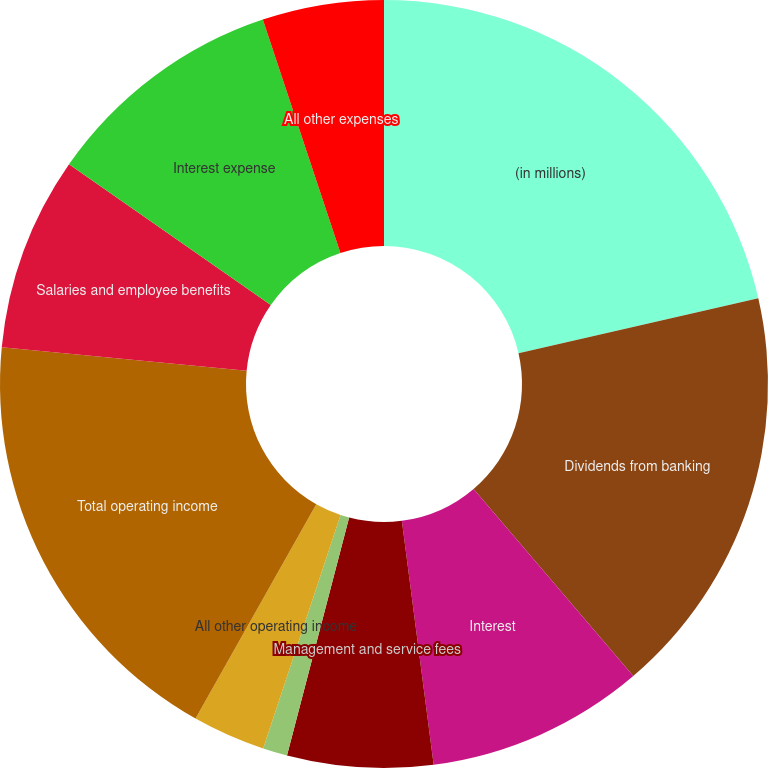Convert chart to OTSL. <chart><loc_0><loc_0><loc_500><loc_500><pie_chart><fcel>(in millions)<fcel>Dividends from banking<fcel>Interest<fcel>Management and service fees<fcel>Equity securities gains<fcel>All other operating income<fcel>Total operating income<fcel>Salaries and employee benefits<fcel>Interest expense<fcel>All other expenses<nl><fcel>21.42%<fcel>17.34%<fcel>9.18%<fcel>6.13%<fcel>1.03%<fcel>3.07%<fcel>18.36%<fcel>8.17%<fcel>10.2%<fcel>5.11%<nl></chart> 